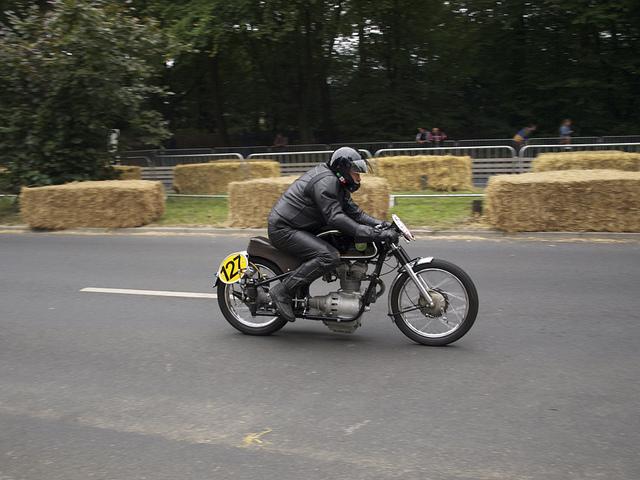What is the number on the motorcycle?
Keep it brief. 127. What is the person below wearing?
Short answer required. Leather. How many bikes are there?
Keep it brief. 1. What kind of motorcycle is that?
Give a very brief answer. Harley. What type of jacket is the man,on the bike wearing?
Quick response, please. Leather. What type of vehicle is the man riding?
Be succinct. Motorcycle. Is there a girl in the photo?
Short answer required. No. Is anyone riding this bike?
Short answer required. Yes. What position is the bike in?
Short answer required. Upright. 